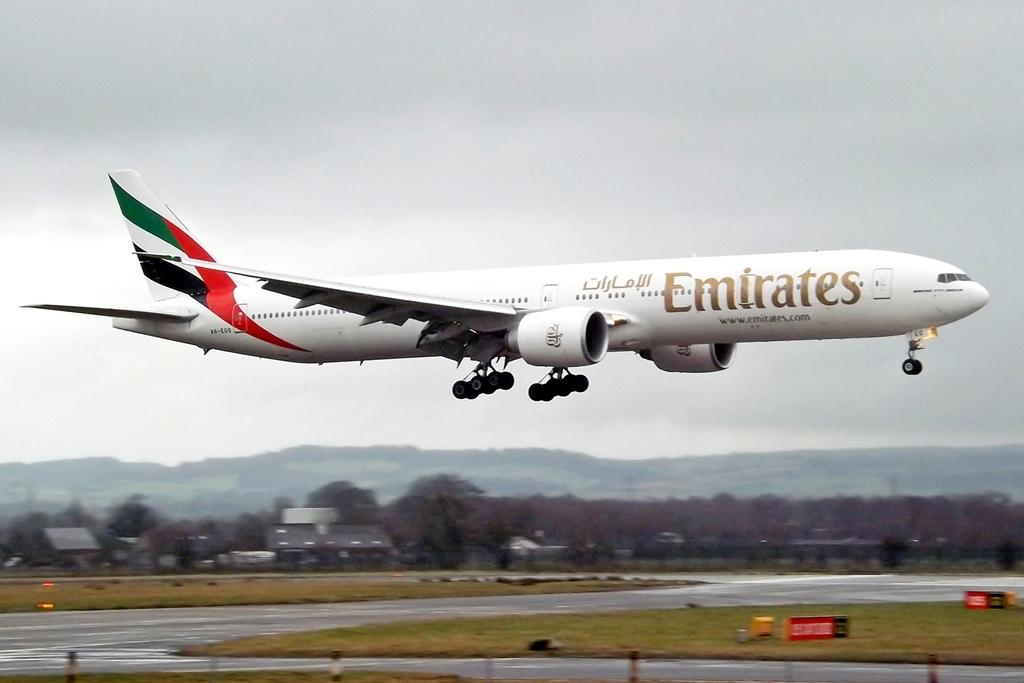What is the main subject in the image? There is an aeroplane in the air in the image. What can be seen at the bottom of the image? There is a road, grassy land, boards, buildings, and trees at the bottom of the image. How is the sky depicted in the image? The sky is covered with clouds in the image. How many pets are visible in the image? There are no pets present in the image. What type of plane is shown in the image? The image only shows an aeroplane in the air, without providing any specific details about the type of plane. 